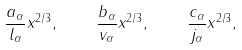<formula> <loc_0><loc_0><loc_500><loc_500>\frac { a _ { \alpha } } { l _ { \alpha } } x ^ { 2 / 3 } , \quad \frac { b _ { \alpha } } { v _ { \alpha } } x ^ { 2 / 3 } , \quad \frac { c _ { \alpha } } { j _ { \alpha } } x ^ { 2 / 3 } ,</formula> 